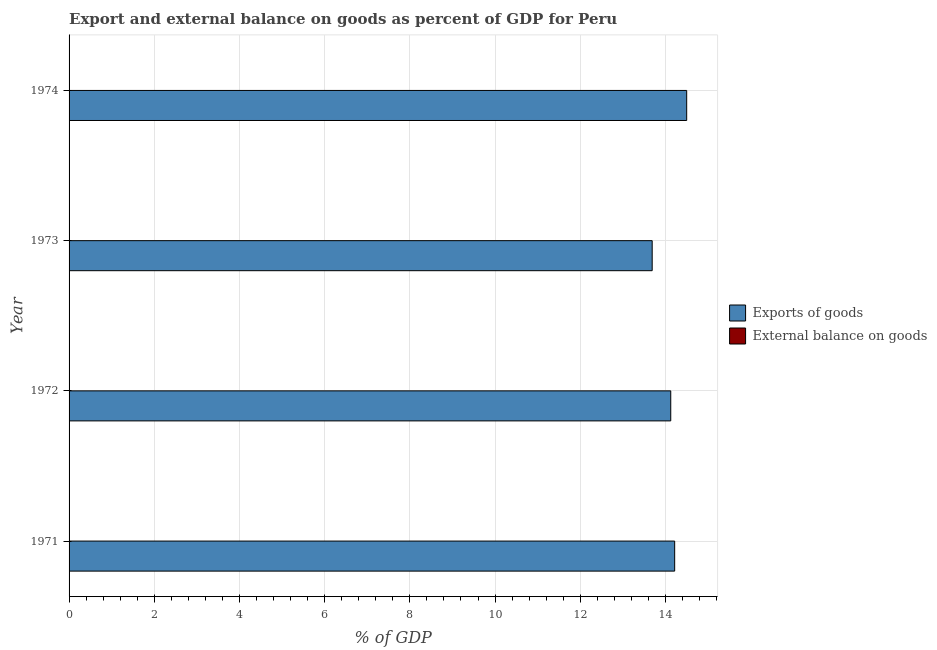How many different coloured bars are there?
Your answer should be very brief. 1. Are the number of bars on each tick of the Y-axis equal?
Provide a succinct answer. Yes. What is the export of goods as percentage of gdp in 1971?
Your answer should be very brief. 14.22. Across all years, what is the maximum export of goods as percentage of gdp?
Provide a succinct answer. 14.5. In which year was the export of goods as percentage of gdp maximum?
Make the answer very short. 1974. What is the total external balance on goods as percentage of gdp in the graph?
Provide a short and direct response. 0. What is the difference between the export of goods as percentage of gdp in 1973 and that in 1974?
Make the answer very short. -0.81. What is the difference between the export of goods as percentage of gdp in 1974 and the external balance on goods as percentage of gdp in 1971?
Ensure brevity in your answer.  14.5. What is the difference between the highest and the second highest export of goods as percentage of gdp?
Provide a short and direct response. 0.28. What is the difference between the highest and the lowest export of goods as percentage of gdp?
Your answer should be compact. 0.81. Are the values on the major ticks of X-axis written in scientific E-notation?
Make the answer very short. No. Does the graph contain any zero values?
Provide a succinct answer. Yes. Does the graph contain grids?
Make the answer very short. Yes. How many legend labels are there?
Your answer should be very brief. 2. How are the legend labels stacked?
Your answer should be compact. Vertical. What is the title of the graph?
Your answer should be compact. Export and external balance on goods as percent of GDP for Peru. Does "Death rate" appear as one of the legend labels in the graph?
Make the answer very short. No. What is the label or title of the X-axis?
Give a very brief answer. % of GDP. What is the label or title of the Y-axis?
Offer a very short reply. Year. What is the % of GDP in Exports of goods in 1971?
Give a very brief answer. 14.22. What is the % of GDP of External balance on goods in 1971?
Ensure brevity in your answer.  0. What is the % of GDP of Exports of goods in 1972?
Offer a very short reply. 14.12. What is the % of GDP in External balance on goods in 1972?
Give a very brief answer. 0. What is the % of GDP in Exports of goods in 1973?
Your answer should be compact. 13.69. What is the % of GDP in External balance on goods in 1973?
Your answer should be very brief. 0. What is the % of GDP in Exports of goods in 1974?
Provide a short and direct response. 14.5. Across all years, what is the maximum % of GDP of Exports of goods?
Your answer should be compact. 14.5. Across all years, what is the minimum % of GDP in Exports of goods?
Your response must be concise. 13.69. What is the total % of GDP of Exports of goods in the graph?
Your answer should be compact. 56.53. What is the total % of GDP in External balance on goods in the graph?
Your answer should be very brief. 0. What is the difference between the % of GDP of Exports of goods in 1971 and that in 1972?
Your answer should be compact. 0.09. What is the difference between the % of GDP of Exports of goods in 1971 and that in 1973?
Make the answer very short. 0.53. What is the difference between the % of GDP of Exports of goods in 1971 and that in 1974?
Your answer should be very brief. -0.28. What is the difference between the % of GDP in Exports of goods in 1972 and that in 1973?
Your answer should be very brief. 0.44. What is the difference between the % of GDP of Exports of goods in 1972 and that in 1974?
Keep it short and to the point. -0.37. What is the difference between the % of GDP in Exports of goods in 1973 and that in 1974?
Offer a terse response. -0.81. What is the average % of GDP in Exports of goods per year?
Keep it short and to the point. 14.13. What is the ratio of the % of GDP of Exports of goods in 1971 to that in 1972?
Your response must be concise. 1.01. What is the ratio of the % of GDP in Exports of goods in 1971 to that in 1973?
Make the answer very short. 1.04. What is the ratio of the % of GDP in Exports of goods in 1971 to that in 1974?
Ensure brevity in your answer.  0.98. What is the ratio of the % of GDP of Exports of goods in 1972 to that in 1973?
Your response must be concise. 1.03. What is the ratio of the % of GDP of Exports of goods in 1972 to that in 1974?
Provide a succinct answer. 0.97. What is the ratio of the % of GDP in Exports of goods in 1973 to that in 1974?
Your answer should be compact. 0.94. What is the difference between the highest and the second highest % of GDP in Exports of goods?
Offer a very short reply. 0.28. What is the difference between the highest and the lowest % of GDP of Exports of goods?
Ensure brevity in your answer.  0.81. 